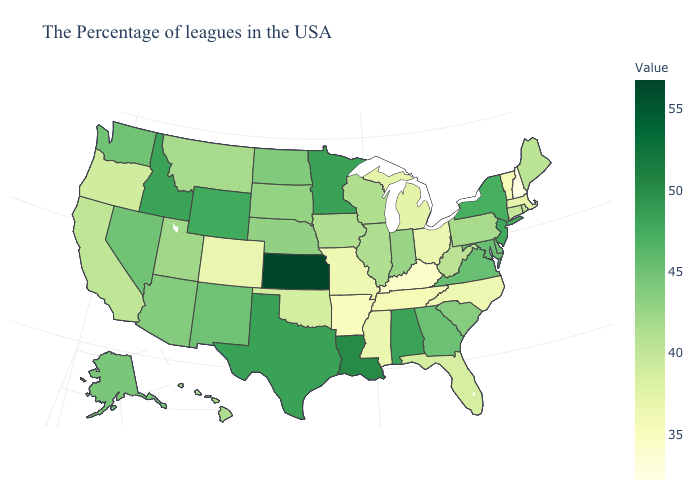Does Florida have a lower value than South Carolina?
Be succinct. Yes. Does Oregon have the lowest value in the USA?
Keep it brief. No. Among the states that border Massachusetts , does Rhode Island have the highest value?
Keep it brief. No. 